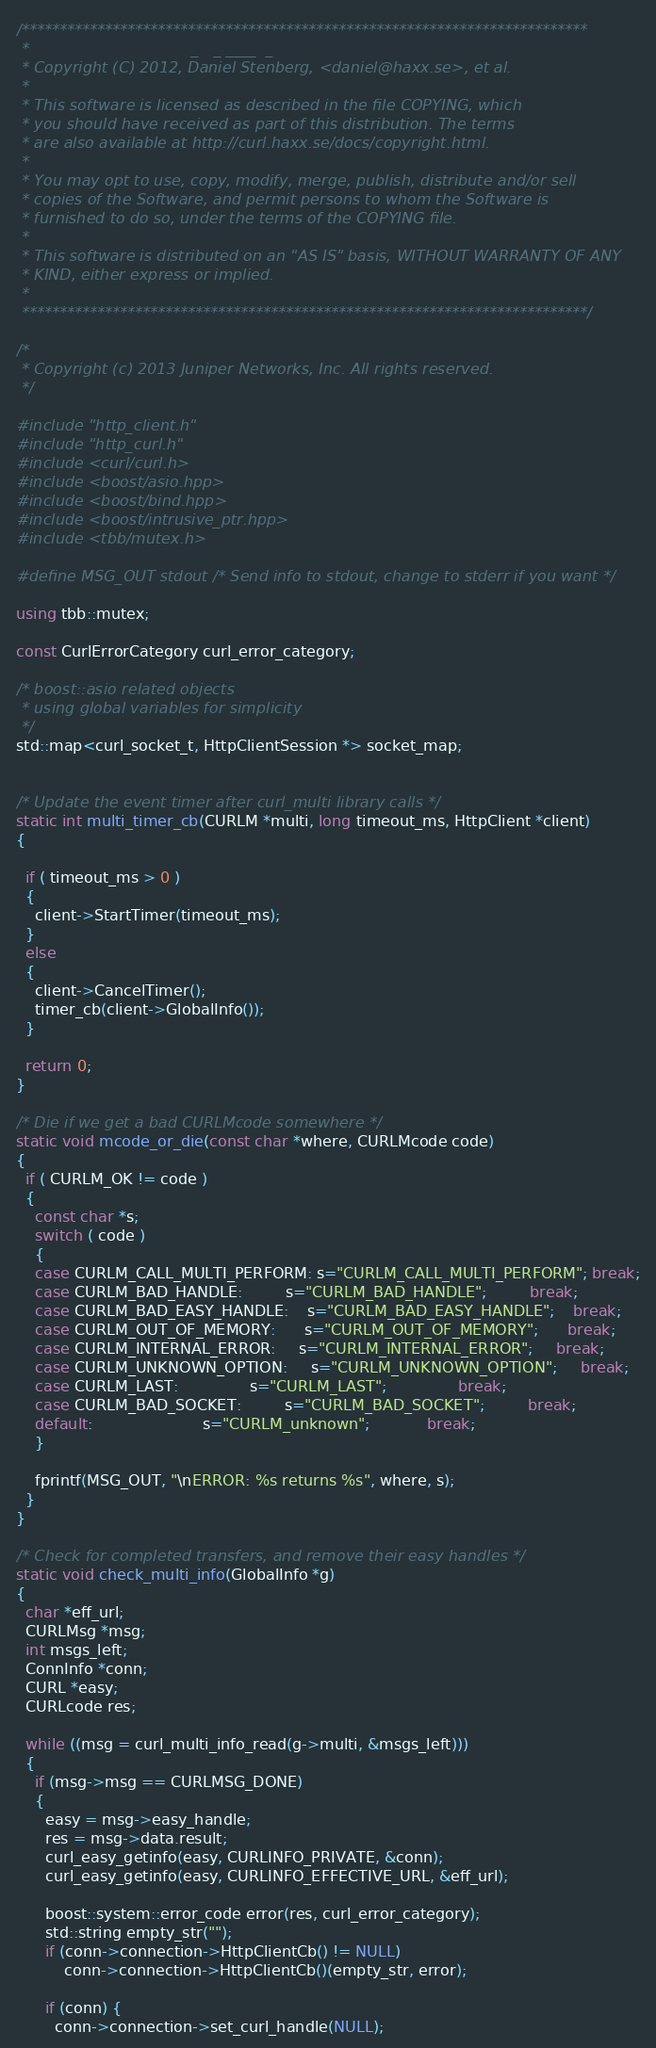<code> <loc_0><loc_0><loc_500><loc_500><_C++_>/***************************************************************************
 *                                  _   _ ____  _
 * Copyright (C) 2012, Daniel Stenberg, <daniel@haxx.se>, et al.
 *
 * This software is licensed as described in the file COPYING, which
 * you should have received as part of this distribution. The terms
 * are also available at http://curl.haxx.se/docs/copyright.html.
 *
 * You may opt to use, copy, modify, merge, publish, distribute and/or sell
 * copies of the Software, and permit persons to whom the Software is
 * furnished to do so, under the terms of the COPYING file.
 *
 * This software is distributed on an "AS IS" basis, WITHOUT WARRANTY OF ANY
 * KIND, either express or implied.
 *
 ***************************************************************************/

/*
 * Copyright (c) 2013 Juniper Networks, Inc. All rights reserved.
 */

#include "http_client.h"
#include "http_curl.h"
#include <curl/curl.h>
#include <boost/asio.hpp>
#include <boost/bind.hpp>
#include <boost/intrusive_ptr.hpp>
#include <tbb/mutex.h>

#define MSG_OUT stdout /* Send info to stdout, change to stderr if you want */

using tbb::mutex;

const CurlErrorCategory curl_error_category;

/* boost::asio related objects
 * using global variables for simplicity
 */
std::map<curl_socket_t, HttpClientSession *> socket_map;


/* Update the event timer after curl_multi library calls */
static int multi_timer_cb(CURLM *multi, long timeout_ms, HttpClient *client)
{

  if ( timeout_ms > 0 )
  {
    client->StartTimer(timeout_ms);
  }
  else
  {
    client->CancelTimer();
    timer_cb(client->GlobalInfo());
  }

  return 0;
}

/* Die if we get a bad CURLMcode somewhere */
static void mcode_or_die(const char *where, CURLMcode code)
{
  if ( CURLM_OK != code )
  {
    const char *s;
    switch ( code )
    {
    case CURLM_CALL_MULTI_PERFORM: s="CURLM_CALL_MULTI_PERFORM"; break;
    case CURLM_BAD_HANDLE:         s="CURLM_BAD_HANDLE";         break;
    case CURLM_BAD_EASY_HANDLE:    s="CURLM_BAD_EASY_HANDLE";    break;
    case CURLM_OUT_OF_MEMORY:      s="CURLM_OUT_OF_MEMORY";      break;
    case CURLM_INTERNAL_ERROR:     s="CURLM_INTERNAL_ERROR";     break;
    case CURLM_UNKNOWN_OPTION:     s="CURLM_UNKNOWN_OPTION";     break;
    case CURLM_LAST:               s="CURLM_LAST";               break;
    case CURLM_BAD_SOCKET:         s="CURLM_BAD_SOCKET";         break;
    default:                       s="CURLM_unknown";            break;
    }

    fprintf(MSG_OUT, "\nERROR: %s returns %s", where, s);
  }
}

/* Check for completed transfers, and remove their easy handles */
static void check_multi_info(GlobalInfo *g)
{
  char *eff_url;
  CURLMsg *msg;
  int msgs_left;
  ConnInfo *conn;
  CURL *easy;
  CURLcode res;

  while ((msg = curl_multi_info_read(g->multi, &msgs_left)))
  {
    if (msg->msg == CURLMSG_DONE)
    {
      easy = msg->easy_handle;
      res = msg->data.result;
      curl_easy_getinfo(easy, CURLINFO_PRIVATE, &conn);
      curl_easy_getinfo(easy, CURLINFO_EFFECTIVE_URL, &eff_url);

      boost::system::error_code error(res, curl_error_category);
      std::string empty_str("");
      if (conn->connection->HttpClientCb() != NULL)
          conn->connection->HttpClientCb()(empty_str, error);

      if (conn) {
        conn->connection->set_curl_handle(NULL);</code> 